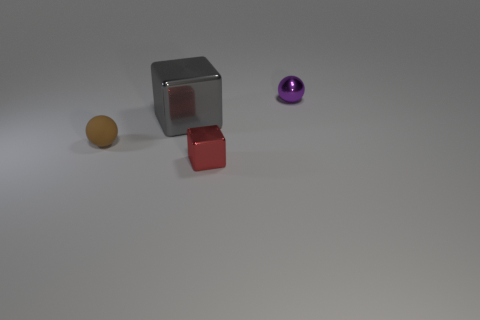There is a metal block that is the same size as the rubber sphere; what color is it?
Provide a succinct answer. Red. Is the tiny purple metallic thing the same shape as the brown matte thing?
Your answer should be compact. Yes. There is a tiny thing that is behind the red cube and in front of the tiny purple thing; what is its material?
Provide a short and direct response. Rubber. What is the size of the metal ball?
Offer a terse response. Small. There is a big object that is the same shape as the tiny red metallic thing; what color is it?
Keep it short and to the point. Gray. Are there any other things that are the same color as the big shiny block?
Ensure brevity in your answer.  No. Is the size of the brown rubber object that is in front of the big gray metal object the same as the shiny block behind the tiny brown sphere?
Offer a terse response. No. Are there an equal number of tiny blocks that are left of the purple thing and brown things that are left of the rubber object?
Your answer should be very brief. No. Is the size of the brown thing the same as the ball behind the brown sphere?
Your answer should be compact. Yes. There is a ball on the right side of the large shiny block; are there any big gray shiny objects that are to the right of it?
Make the answer very short. No. 